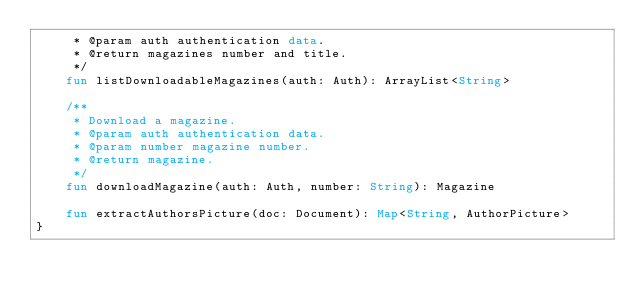<code> <loc_0><loc_0><loc_500><loc_500><_Kotlin_>     * @param auth authentication data.
     * @return magazines number and title.
     */
    fun listDownloadableMagazines(auth: Auth): ArrayList<String>

    /**
     * Download a magazine.
     * @param auth authentication data.
     * @param number magazine number.
     * @return magazine.
     */
    fun downloadMagazine(auth: Auth, number: String): Magazine

    fun extractAuthorsPicture(doc: Document): Map<String, AuthorPicture>
}
</code> 